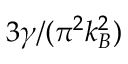<formula> <loc_0><loc_0><loc_500><loc_500>3 \gamma / ( \pi ^ { 2 } k _ { B } ^ { 2 } )</formula> 